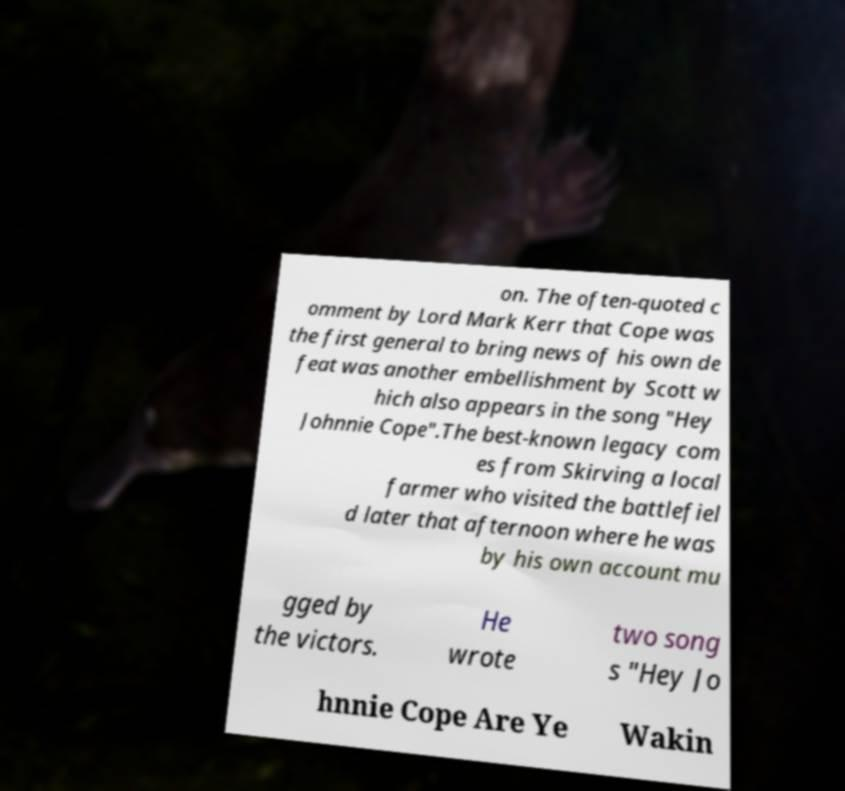Could you extract and type out the text from this image? on. The often-quoted c omment by Lord Mark Kerr that Cope was the first general to bring news of his own de feat was another embellishment by Scott w hich also appears in the song "Hey Johnnie Cope".The best-known legacy com es from Skirving a local farmer who visited the battlefiel d later that afternoon where he was by his own account mu gged by the victors. He wrote two song s "Hey Jo hnnie Cope Are Ye Wakin 